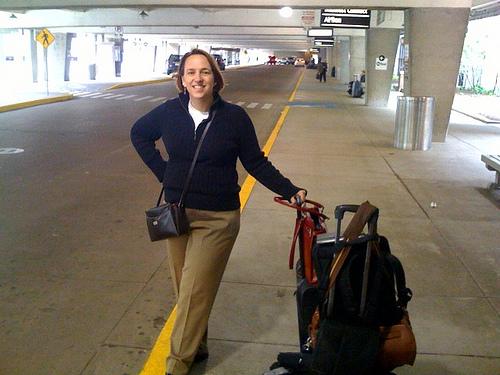What material is the floor made of?
Write a very short answer. Concrete. Do you see any service workers?
Keep it brief. No. Is the woman in this photo wearing an equestrian helmet?
Concise answer only. No. Is this woman going on a trip?
Give a very brief answer. Yes. Where is the clock?
Quick response, please. Nowhere. How many animals are there?
Concise answer only. 0. Is she wearing a backpack?
Keep it brief. No. Are the pilots standing on any stripes on the floor?
Quick response, please. No. What is this lady doing?
Concise answer only. Waiting. 